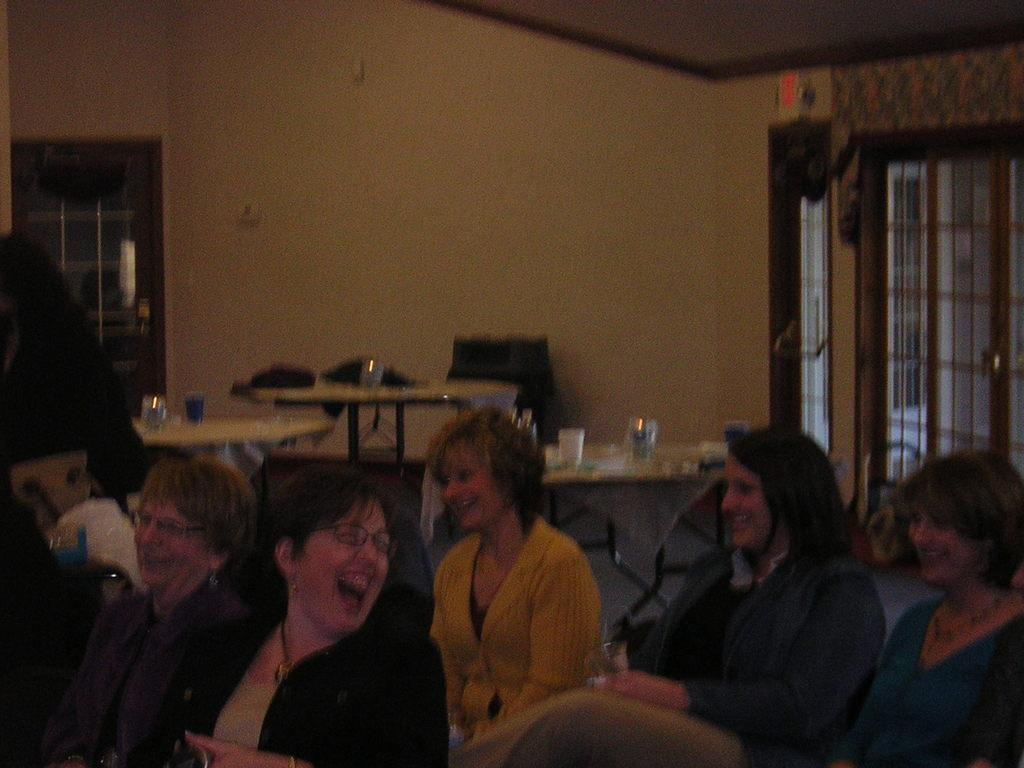What are the people in the image doing? The people in the image are sitting on chairs. What can be seen on the tables in the image? There are glasses and other objects on the tables. What is visible in the background of the image? There is a wall and windows in the background. What type of rock can be seen in the image? There is no rock present in the image. What need are the people in the image trying to fulfill? The image does not provide information about any specific needs the people might be trying to fulfill. 